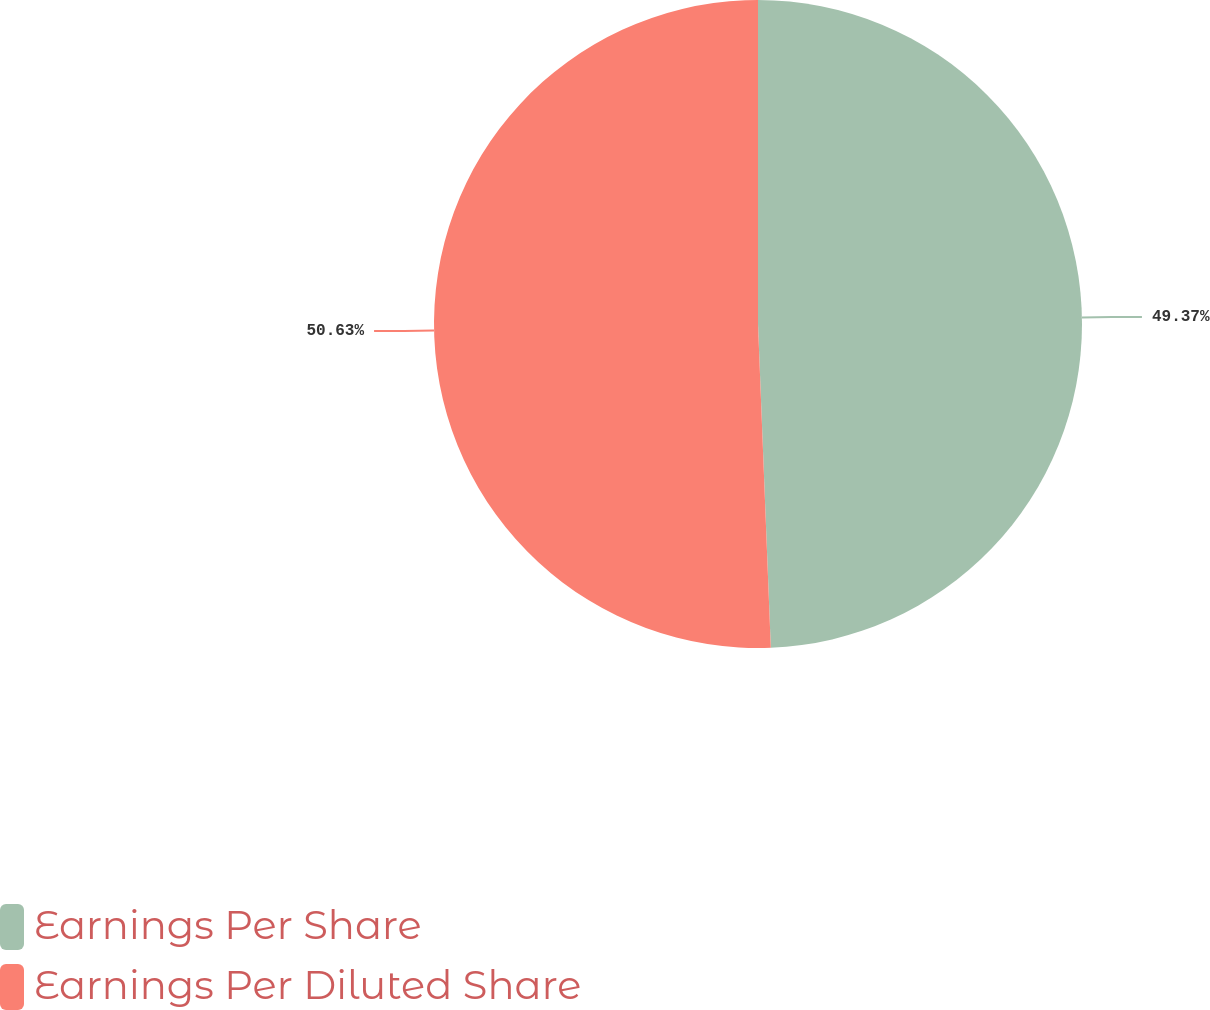<chart> <loc_0><loc_0><loc_500><loc_500><pie_chart><fcel>Earnings Per Share<fcel>Earnings Per Diluted Share<nl><fcel>49.37%<fcel>50.63%<nl></chart> 